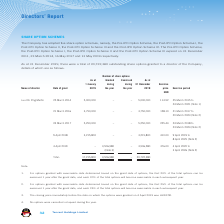According to Tencent's financial document, How many share option schemes has the Company adopted? According to the financial document, five. The relevant text states: "The Company has adopted five share option schemes, namely, the Pre-IPO Option Scheme, the Post-IPO Option Scheme I, the..." Also, When did the Pre-IPO Option Scheme expire? According to the financial document, 31 December 2011. The relevant text states: "II and the Post-IPO Option Scheme III expired on 31 December 2011, 23 March 2014, 16 May 2017 and 13 May 2019 respectively...." Also, When did the Post-IPO Option Scheme III expire? According to the financial document, 13 May 2019. The relevant text states: "2011, 23 March 2014, 16 May 2017 and 13 May 2019 respectively...." Also, can you calculate: How many percent of the total shares granted as at 1 January was the 25 March 2014 grant? Based on the calculation: 5,000,000/17,215,800, the result is 29.04 (percentage). This is based on the information: "Lau Chi Ping Martin 25 March 2014 5,000,000 – – 5,000,000 114.52 25 March 2015 to Total: 17,215,800 3,506,580 – 20,722,380..." The key data points involved are: 17,215,800, 5,000,000. Also, can you calculate: How many percent of the total shares granted as at 1 January was the 21 March 2016 grant? Based on the calculation: 3,750,000/17,215,800, the result is 21.78 (percentage). This is based on the information: "21 March 2016 3,750,000 – – 3,750,000 158.10 21 March 2017 to Total: 17,215,800 3,506,580 – 20,722,380..." The key data points involved are: 17,215,800, 3,750,000. Also, can you calculate: How many percent of the total shares granted as at 1 January was the 9 April 2018 grant? Based on the calculation: 3,215,800/17,215,800, the result is 18.68 (percentage). This is based on the information: "9 April 2018 3,215,800 – – 3,215,800 410.00 9 April 2019 to Total: 17,215,800 3,506,580 – 20,722,380..." The key data points involved are: 17,215,800, 3,215,800. 